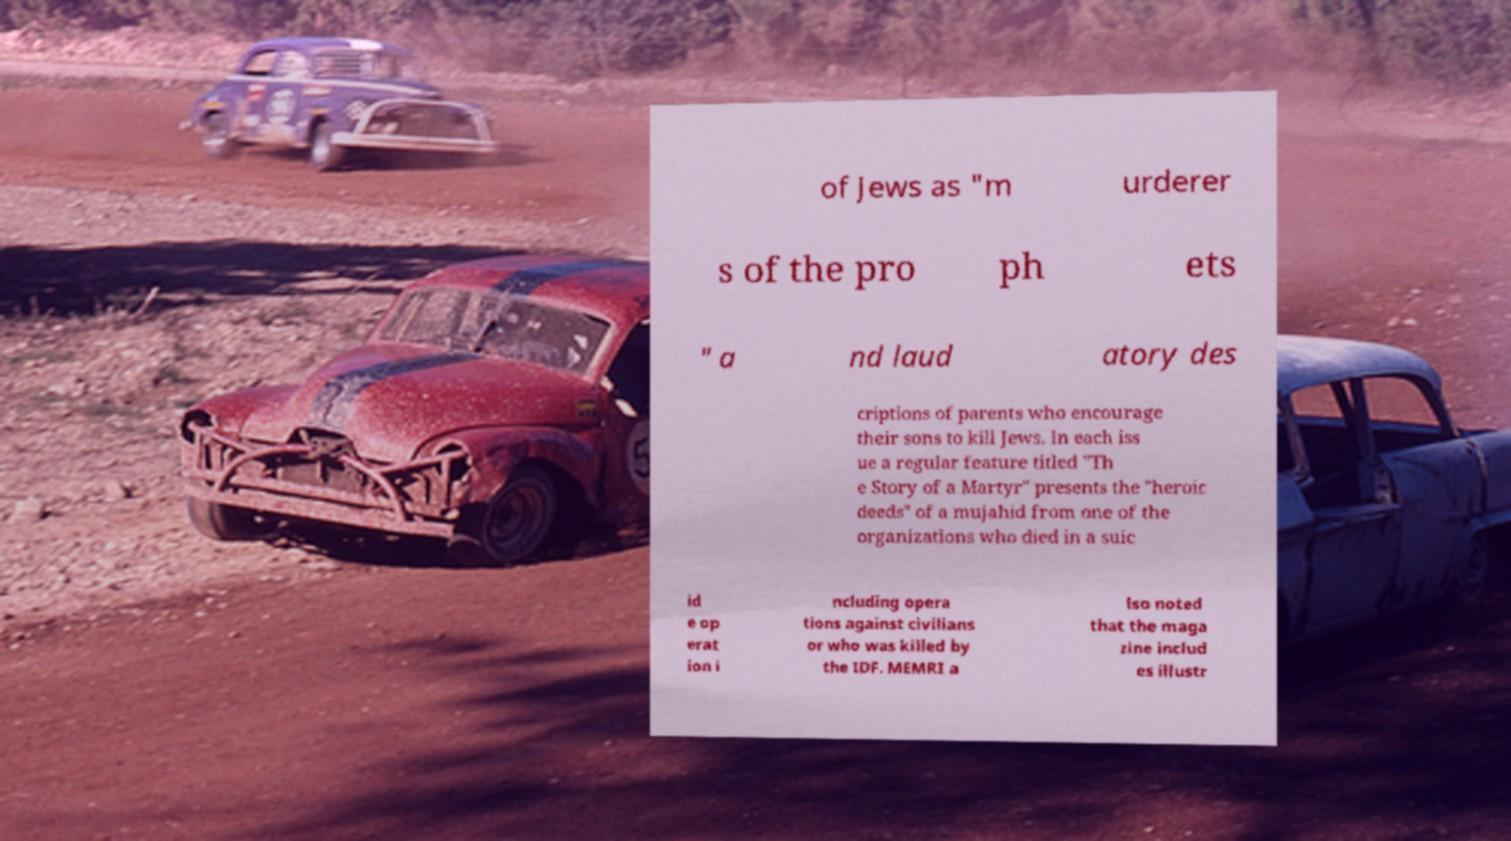I need the written content from this picture converted into text. Can you do that? of Jews as "m urderer s of the pro ph ets " a nd laud atory des criptions of parents who encourage their sons to kill Jews. In each iss ue a regular feature titled "Th e Story of a Martyr" presents the "heroic deeds" of a mujahid from one of the organizations who died in a suic id e op erat ion i ncluding opera tions against civilians or who was killed by the IDF. MEMRI a lso noted that the maga zine includ es illustr 